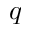<formula> <loc_0><loc_0><loc_500><loc_500>^ { q }</formula> 